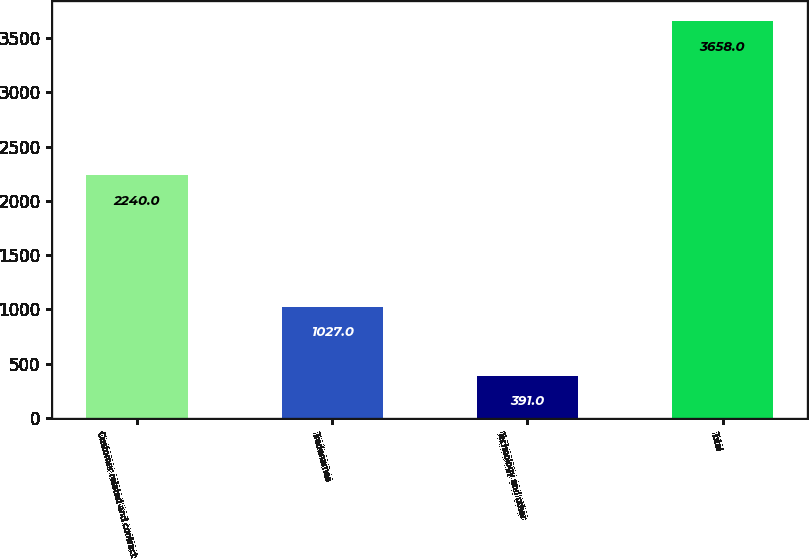Convert chart to OTSL. <chart><loc_0><loc_0><loc_500><loc_500><bar_chart><fcel>Customer related and contract<fcel>Tradenames<fcel>Technology and other<fcel>Total<nl><fcel>2240<fcel>1027<fcel>391<fcel>3658<nl></chart> 